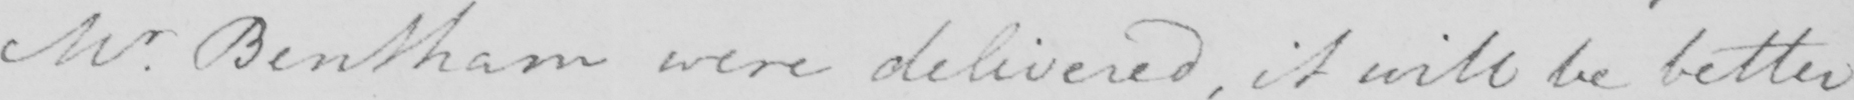What does this handwritten line say? Mr . Bentham were delivered , it will be better 